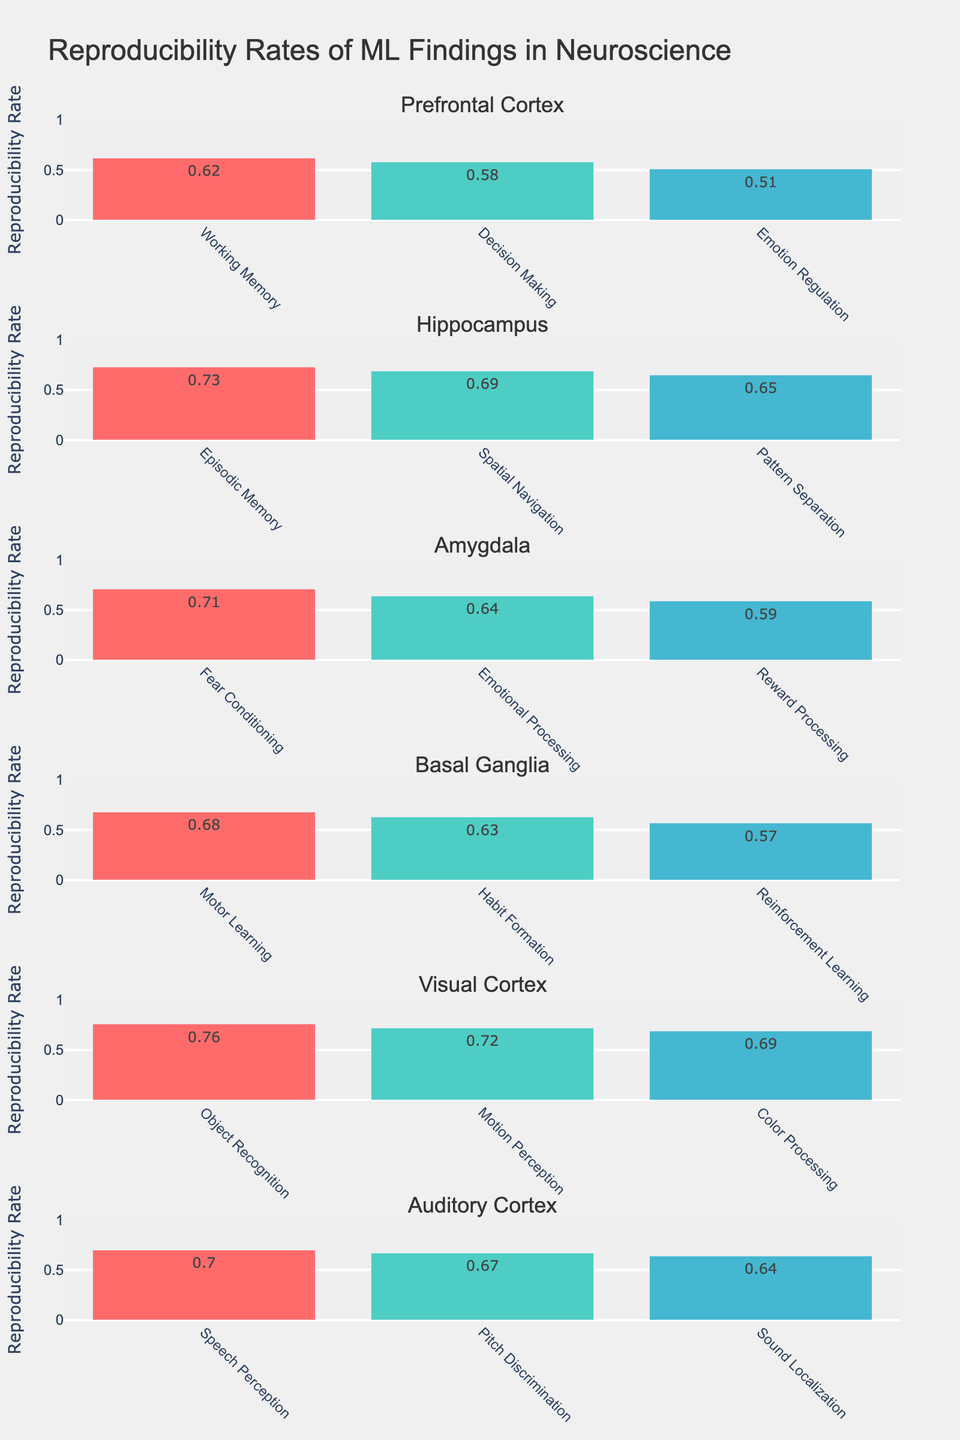What is the title of the figure? The title of the figure is located at the top of the plot layout, which typically summarizes the content of the visual representation.
Answer: "Reproducibility Rates of ML Findings in Neuroscience" Which brain region has the highest reproducibility rate in any cognitive domain? Look at all brain regions and their associated cognitive domains to identify the highest reproducibility rate. The Visual Cortex in Object Recognition stands out with the highest value.
Answer: Visual Cortex in Object Recognition How does the reproducibility rate of Decision Making in the Prefrontal Cortex compare to that of Habit Formation in the Basal Ganglia? Locate the reproducibility rates of both cognitive domains in the respective subplots. Decision Making in the Prefrontal Cortex has 0.58, whereas Habit Formation in the Basal Ganglia has 0.63.
Answer: Habit Formation has a higher rate than Decision Making Which cognitive domain in the Hippocampus has the lowest reproducibility rate, and what is that rate? Check the subplots for the Hippocampus and identify the cognitive domain with the lowest rate. Pattern Separation has the lowest rate at 0.65.
Answer: Pattern Separation at 0.65 What is the average reproducibility rate of cognitive domains within the Amygdala? Sum the reproducibility rates of all cognitive domains within the Amygdala (0.71 + 0.64 + 0.59) and divide by the number of domains (3). The calculation is (0.71 + 0.64 + 0.59) / 3 ≈ 0.65.
Answer: Approximately 0.65 Which cognitive domain in the Prefrontal Cortex has the highest reproducibility rate and what is it? Look within the Prefrontal Cortex subplot and identify the highest reproducibility rate among the listed cognitive domains. The highest is Working Memory at 0.62.
Answer: Working Memory at 0.62 Is the reproducibility rate of Speech Perception in the Auditory Cortex greater than that of Color Processing in the Visual Cortex? Compare the reproducibility rates of Speech Perception in the Auditory Cortex (0.70) and Color Processing in the Visual Cortex (0.69).
Answer: Yes, it is greater How many cognitive domains are represented in the Visual Cortex subplot? Count the number of distinct cognitive domains listed under Visual Cortex.
Answer: 3 domains What is the total number of brain regions represented in the grids of subplots? Count the distinct brain regions listed in the data.
Answer: 5 brain regions Which brain region has the most cognitive domains assessed? Count the number of cognitive domains for each brain region and determine the one with the highest count. The Prefrontal Cortex has three cognitive domains.
Answer: Prefrontal Cortex 